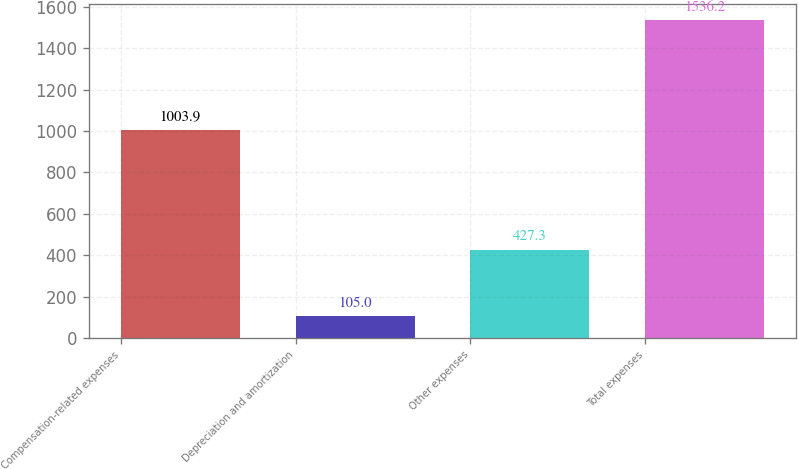Convert chart to OTSL. <chart><loc_0><loc_0><loc_500><loc_500><bar_chart><fcel>Compensation-related expenses<fcel>Depreciation and amortization<fcel>Other expenses<fcel>Total expenses<nl><fcel>1003.9<fcel>105<fcel>427.3<fcel>1536.2<nl></chart> 